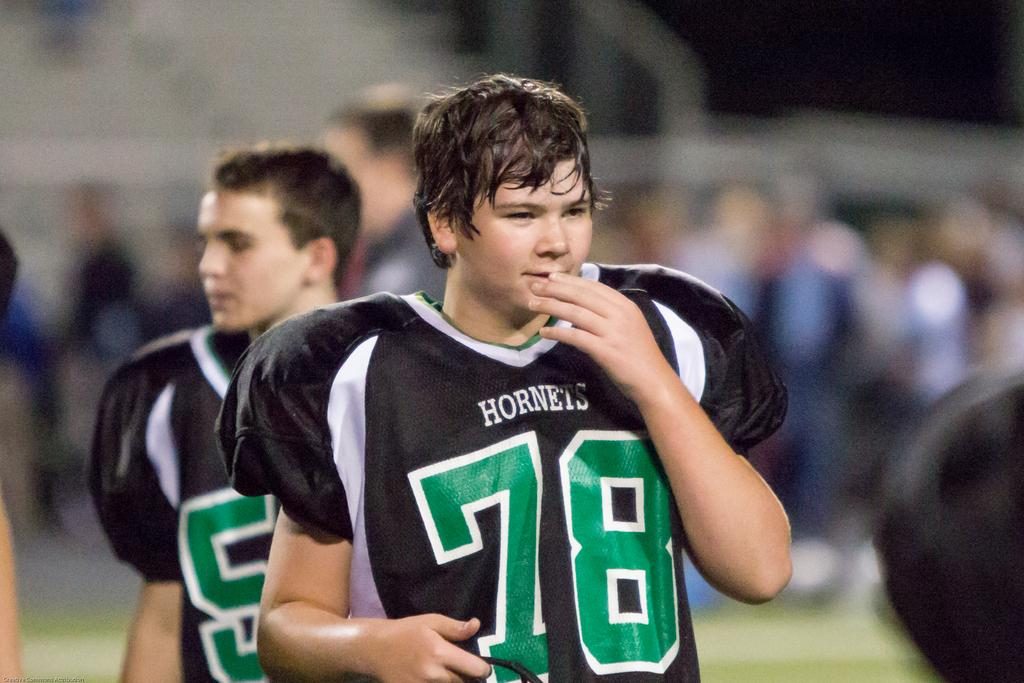What can be seen in the foreground of the image? There are men in the foreground of the image. How would you describe the background of the image? The background of the image is blurred. What language are the men speaking in the image? There is no information about the language being spoken in the image, as it is not mentioned in the provided facts. 